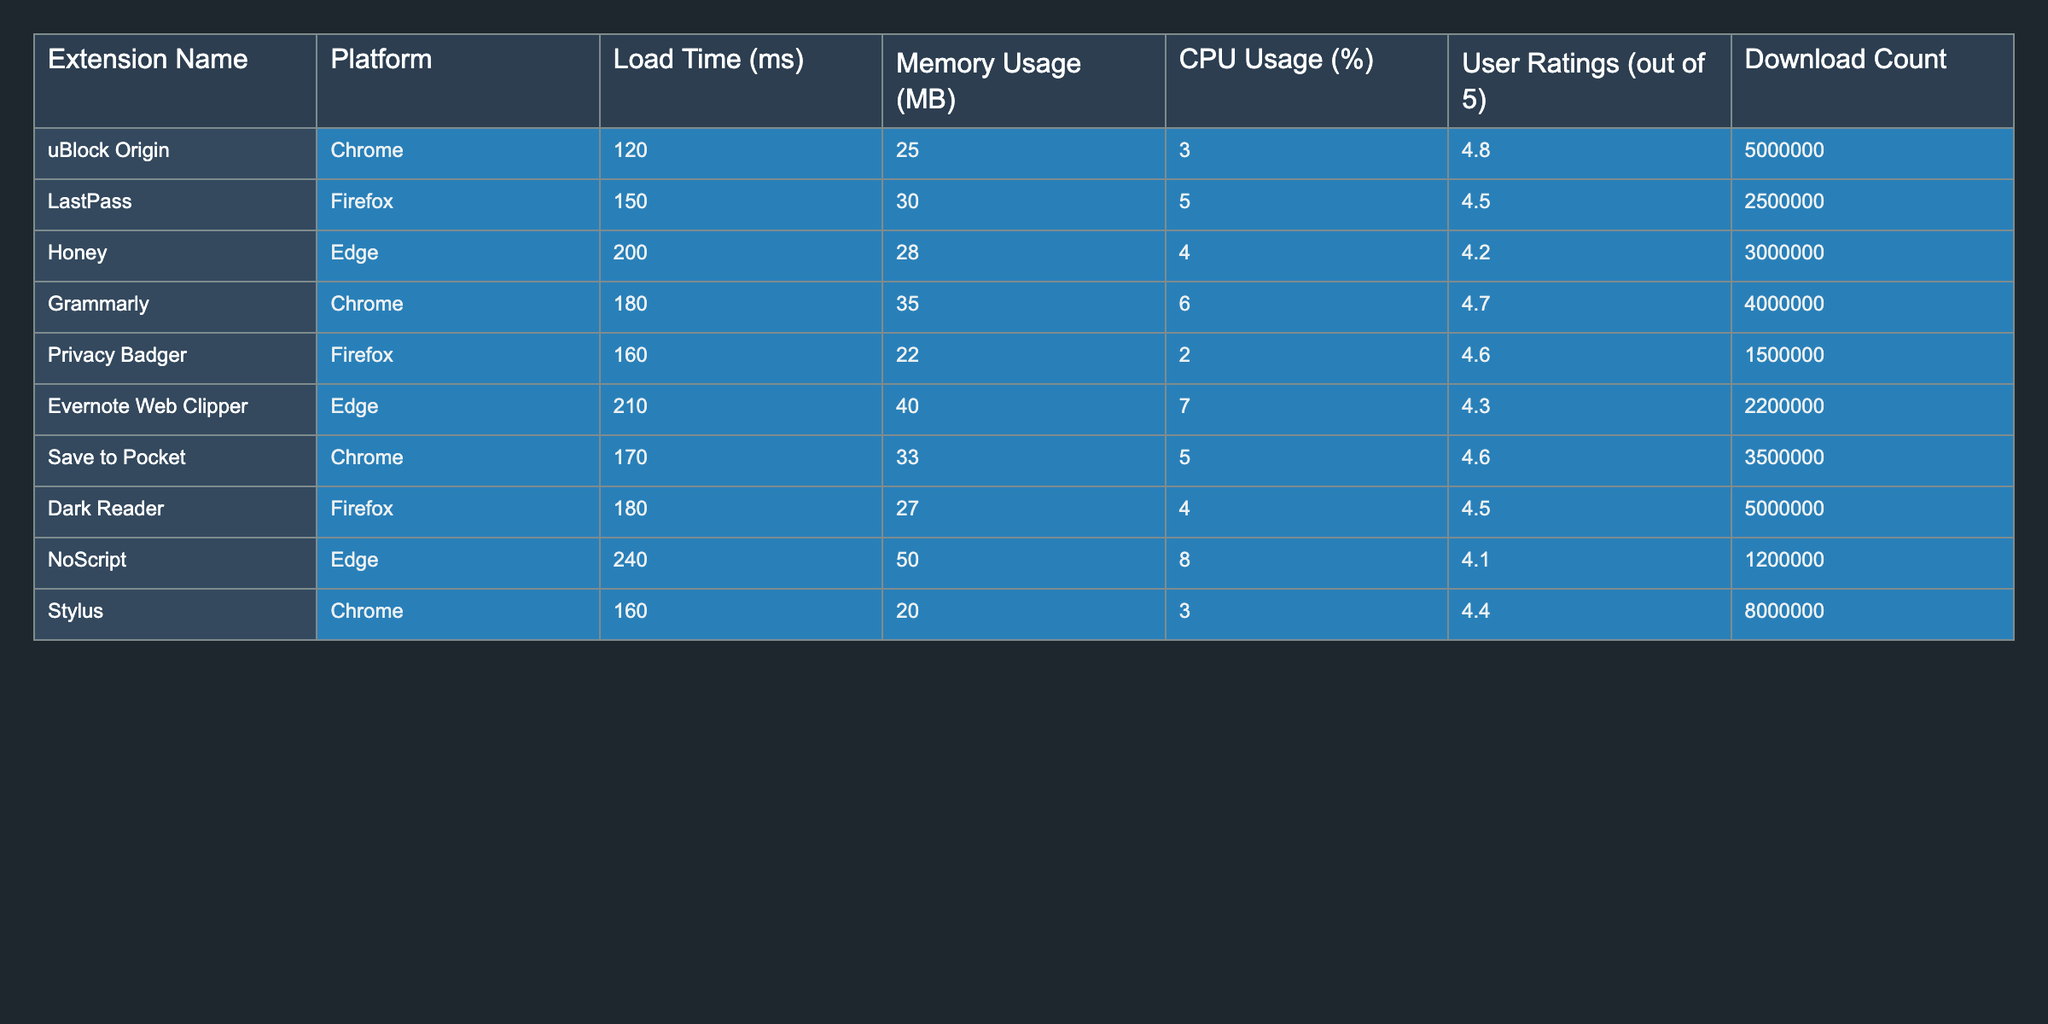What is the load time of uBlock Origin on Chrome? The load time for uBlock Origin is explicitly listed in the table, showing it as 120 milliseconds on the Chrome platform.
Answer: 120 ms Which extension has the highest memory usage? From the memory usage column, it can be observed that NoScript on the Edge platform has the highest memory usage of 50 MB, while the other extensions have lower values.
Answer: NoScript, 50 MB What is the average CPU usage across all extensions listed? To find the average CPU usage, we first sum the CPU usage values: 3 + 5 + 4 + 6 + 2 + 7 + 5 + 4 + 8 + 3 = 43. We then divide this sum by the number of extensions, which is 10. Therefore, the average CPU usage is 43 / 10 = 4.3%.
Answer: 4.3% Does Honey have a higher user rating than Grammarly? By comparing the user ratings in the table, Honey has a rating of 4.2, while Grammarly has a rating of 4.7. Since 4.2 is less than 4.7, the statement is false.
Answer: No Which platform has the lowest average load time? To determine the platform with the lowest average load time, we will sum and then average the load times for each platform: Chrome (120 + 180 + 170 + 160 = 630; 630 / 4 = 157.5), Firefox (150 + 160 + 180 = 490; 490 / 3 = 163.3), Edge (200 + 210 + 240 = 650; 650 / 3 = 216.7). Comparing these averages, Chrome has the lowest average load time of 157.5 ms.
Answer: Chrome, 157.5 ms Are there more total downloads for extensions on the Chrome platform than on the Firefox platform? By adding the download counts from the table, Chrome has (5000000 + 4000000 + 3500000 + 8000000 = 22500000) and Firefox has (2500000 + 1500000 + 5000000 = 9500000). Since 22500000 is greater than 9500000, the answer is yes.
Answer: Yes 